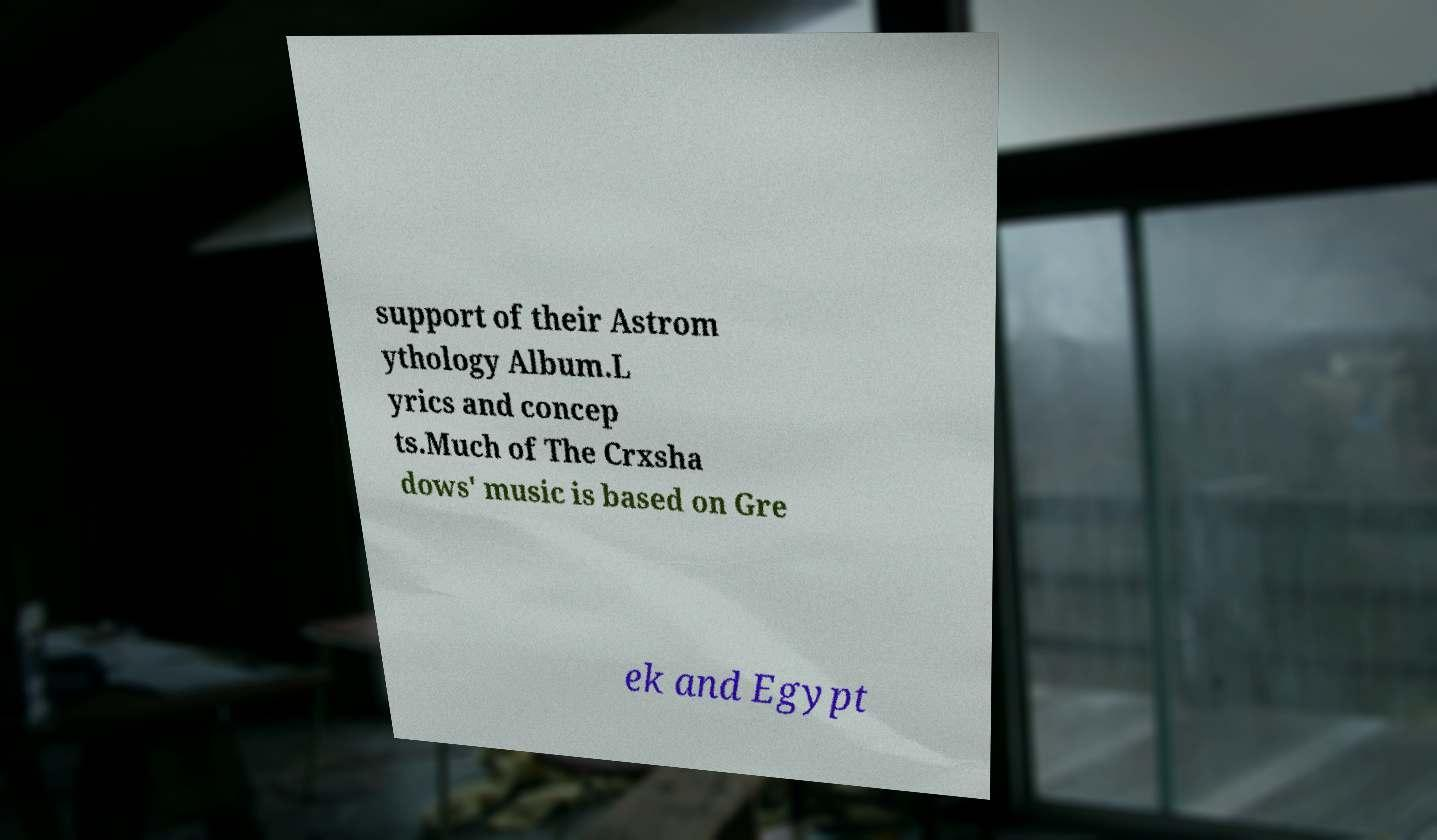Please identify and transcribe the text found in this image. support of their Astrom ythology Album.L yrics and concep ts.Much of The Crxsha dows' music is based on Gre ek and Egypt 